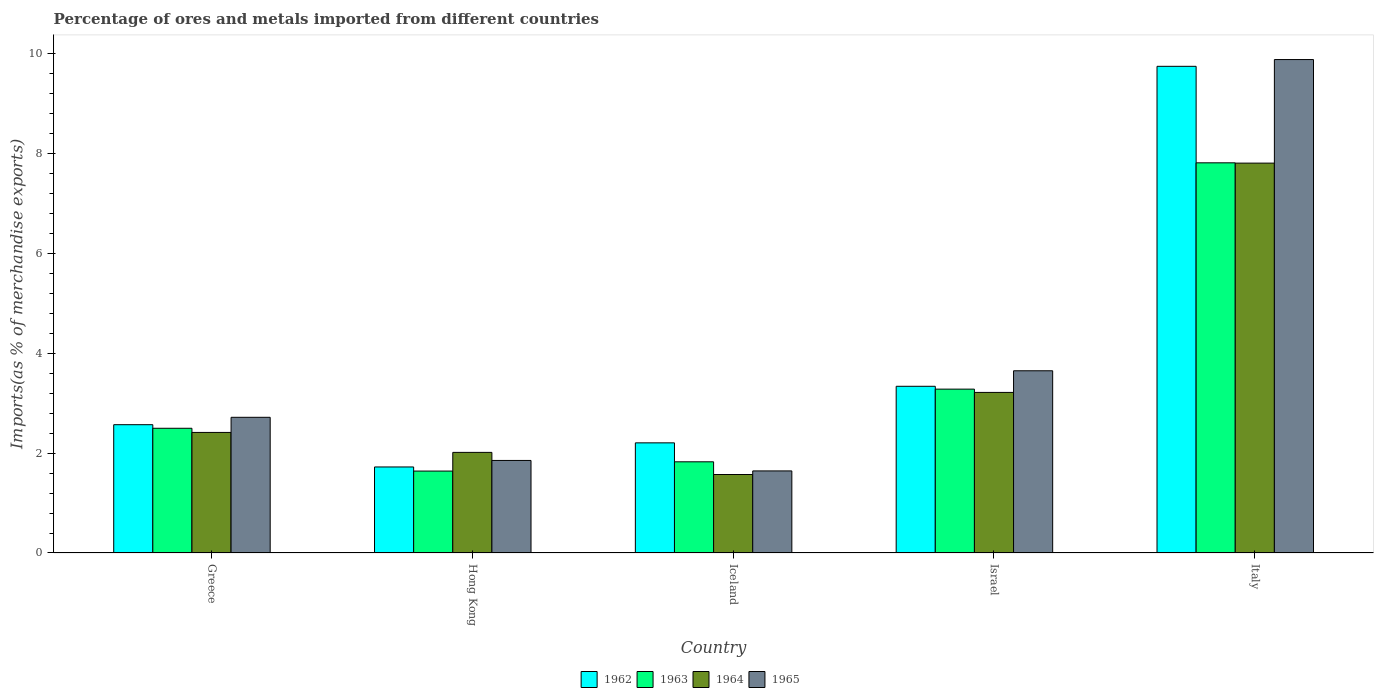How many different coloured bars are there?
Your answer should be compact. 4. Are the number of bars on each tick of the X-axis equal?
Your response must be concise. Yes. How many bars are there on the 1st tick from the left?
Your response must be concise. 4. What is the percentage of imports to different countries in 1964 in Greece?
Offer a terse response. 2.42. Across all countries, what is the maximum percentage of imports to different countries in 1965?
Give a very brief answer. 9.89. Across all countries, what is the minimum percentage of imports to different countries in 1963?
Keep it short and to the point. 1.64. What is the total percentage of imports to different countries in 1965 in the graph?
Make the answer very short. 19.76. What is the difference between the percentage of imports to different countries in 1962 in Iceland and that in Israel?
Provide a short and direct response. -1.13. What is the difference between the percentage of imports to different countries in 1962 in Iceland and the percentage of imports to different countries in 1963 in Italy?
Provide a succinct answer. -5.61. What is the average percentage of imports to different countries in 1964 per country?
Provide a succinct answer. 3.41. What is the difference between the percentage of imports to different countries of/in 1964 and percentage of imports to different countries of/in 1962 in Iceland?
Make the answer very short. -0.63. What is the ratio of the percentage of imports to different countries in 1963 in Hong Kong to that in Iceland?
Your response must be concise. 0.9. Is the percentage of imports to different countries in 1964 in Greece less than that in Italy?
Provide a short and direct response. Yes. What is the difference between the highest and the second highest percentage of imports to different countries in 1962?
Your response must be concise. 7.18. What is the difference between the highest and the lowest percentage of imports to different countries in 1962?
Offer a very short reply. 8.03. What does the 2nd bar from the right in Italy represents?
Give a very brief answer. 1964. Is it the case that in every country, the sum of the percentage of imports to different countries in 1963 and percentage of imports to different countries in 1965 is greater than the percentage of imports to different countries in 1964?
Make the answer very short. Yes. Are the values on the major ticks of Y-axis written in scientific E-notation?
Provide a short and direct response. No. Does the graph contain any zero values?
Keep it short and to the point. No. Where does the legend appear in the graph?
Keep it short and to the point. Bottom center. How many legend labels are there?
Offer a terse response. 4. What is the title of the graph?
Ensure brevity in your answer.  Percentage of ores and metals imported from different countries. Does "1999" appear as one of the legend labels in the graph?
Offer a terse response. No. What is the label or title of the X-axis?
Your response must be concise. Country. What is the label or title of the Y-axis?
Ensure brevity in your answer.  Imports(as % of merchandise exports). What is the Imports(as % of merchandise exports) of 1962 in Greece?
Your answer should be very brief. 2.57. What is the Imports(as % of merchandise exports) of 1963 in Greece?
Your response must be concise. 2.5. What is the Imports(as % of merchandise exports) of 1964 in Greece?
Your answer should be compact. 2.42. What is the Imports(as % of merchandise exports) of 1965 in Greece?
Ensure brevity in your answer.  2.72. What is the Imports(as % of merchandise exports) of 1962 in Hong Kong?
Keep it short and to the point. 1.72. What is the Imports(as % of merchandise exports) of 1963 in Hong Kong?
Your answer should be compact. 1.64. What is the Imports(as % of merchandise exports) in 1964 in Hong Kong?
Offer a terse response. 2.02. What is the Imports(as % of merchandise exports) of 1965 in Hong Kong?
Provide a short and direct response. 1.85. What is the Imports(as % of merchandise exports) of 1962 in Iceland?
Offer a very short reply. 2.21. What is the Imports(as % of merchandise exports) in 1963 in Iceland?
Your answer should be compact. 1.83. What is the Imports(as % of merchandise exports) of 1964 in Iceland?
Ensure brevity in your answer.  1.57. What is the Imports(as % of merchandise exports) of 1965 in Iceland?
Your answer should be compact. 1.64. What is the Imports(as % of merchandise exports) in 1962 in Israel?
Give a very brief answer. 3.34. What is the Imports(as % of merchandise exports) in 1963 in Israel?
Make the answer very short. 3.28. What is the Imports(as % of merchandise exports) in 1964 in Israel?
Make the answer very short. 3.22. What is the Imports(as % of merchandise exports) of 1965 in Israel?
Your answer should be very brief. 3.65. What is the Imports(as % of merchandise exports) of 1962 in Italy?
Offer a very short reply. 9.75. What is the Imports(as % of merchandise exports) of 1963 in Italy?
Provide a succinct answer. 7.82. What is the Imports(as % of merchandise exports) in 1964 in Italy?
Provide a short and direct response. 7.81. What is the Imports(as % of merchandise exports) in 1965 in Italy?
Provide a short and direct response. 9.89. Across all countries, what is the maximum Imports(as % of merchandise exports) in 1962?
Offer a terse response. 9.75. Across all countries, what is the maximum Imports(as % of merchandise exports) of 1963?
Ensure brevity in your answer.  7.82. Across all countries, what is the maximum Imports(as % of merchandise exports) of 1964?
Your response must be concise. 7.81. Across all countries, what is the maximum Imports(as % of merchandise exports) in 1965?
Ensure brevity in your answer.  9.89. Across all countries, what is the minimum Imports(as % of merchandise exports) of 1962?
Provide a short and direct response. 1.72. Across all countries, what is the minimum Imports(as % of merchandise exports) in 1963?
Your answer should be compact. 1.64. Across all countries, what is the minimum Imports(as % of merchandise exports) of 1964?
Your response must be concise. 1.57. Across all countries, what is the minimum Imports(as % of merchandise exports) in 1965?
Your response must be concise. 1.64. What is the total Imports(as % of merchandise exports) of 1962 in the graph?
Your answer should be compact. 19.59. What is the total Imports(as % of merchandise exports) of 1963 in the graph?
Your answer should be compact. 17.07. What is the total Imports(as % of merchandise exports) in 1964 in the graph?
Your response must be concise. 17.03. What is the total Imports(as % of merchandise exports) in 1965 in the graph?
Keep it short and to the point. 19.76. What is the difference between the Imports(as % of merchandise exports) in 1962 in Greece and that in Hong Kong?
Make the answer very short. 0.85. What is the difference between the Imports(as % of merchandise exports) of 1963 in Greece and that in Hong Kong?
Give a very brief answer. 0.86. What is the difference between the Imports(as % of merchandise exports) of 1964 in Greece and that in Hong Kong?
Your response must be concise. 0.4. What is the difference between the Imports(as % of merchandise exports) in 1965 in Greece and that in Hong Kong?
Keep it short and to the point. 0.86. What is the difference between the Imports(as % of merchandise exports) in 1962 in Greece and that in Iceland?
Make the answer very short. 0.36. What is the difference between the Imports(as % of merchandise exports) of 1963 in Greece and that in Iceland?
Offer a terse response. 0.67. What is the difference between the Imports(as % of merchandise exports) of 1964 in Greece and that in Iceland?
Your answer should be very brief. 0.84. What is the difference between the Imports(as % of merchandise exports) of 1965 in Greece and that in Iceland?
Provide a succinct answer. 1.07. What is the difference between the Imports(as % of merchandise exports) in 1962 in Greece and that in Israel?
Make the answer very short. -0.77. What is the difference between the Imports(as % of merchandise exports) of 1963 in Greece and that in Israel?
Offer a very short reply. -0.78. What is the difference between the Imports(as % of merchandise exports) of 1964 in Greece and that in Israel?
Offer a terse response. -0.8. What is the difference between the Imports(as % of merchandise exports) of 1965 in Greece and that in Israel?
Your response must be concise. -0.93. What is the difference between the Imports(as % of merchandise exports) of 1962 in Greece and that in Italy?
Provide a short and direct response. -7.18. What is the difference between the Imports(as % of merchandise exports) in 1963 in Greece and that in Italy?
Your answer should be compact. -5.32. What is the difference between the Imports(as % of merchandise exports) in 1964 in Greece and that in Italy?
Provide a short and direct response. -5.4. What is the difference between the Imports(as % of merchandise exports) of 1965 in Greece and that in Italy?
Your answer should be compact. -7.17. What is the difference between the Imports(as % of merchandise exports) of 1962 in Hong Kong and that in Iceland?
Ensure brevity in your answer.  -0.48. What is the difference between the Imports(as % of merchandise exports) in 1963 in Hong Kong and that in Iceland?
Provide a succinct answer. -0.19. What is the difference between the Imports(as % of merchandise exports) in 1964 in Hong Kong and that in Iceland?
Keep it short and to the point. 0.44. What is the difference between the Imports(as % of merchandise exports) in 1965 in Hong Kong and that in Iceland?
Provide a short and direct response. 0.21. What is the difference between the Imports(as % of merchandise exports) of 1962 in Hong Kong and that in Israel?
Provide a succinct answer. -1.62. What is the difference between the Imports(as % of merchandise exports) of 1963 in Hong Kong and that in Israel?
Give a very brief answer. -1.64. What is the difference between the Imports(as % of merchandise exports) in 1964 in Hong Kong and that in Israel?
Give a very brief answer. -1.2. What is the difference between the Imports(as % of merchandise exports) in 1965 in Hong Kong and that in Israel?
Provide a short and direct response. -1.8. What is the difference between the Imports(as % of merchandise exports) in 1962 in Hong Kong and that in Italy?
Make the answer very short. -8.03. What is the difference between the Imports(as % of merchandise exports) of 1963 in Hong Kong and that in Italy?
Offer a terse response. -6.18. What is the difference between the Imports(as % of merchandise exports) of 1964 in Hong Kong and that in Italy?
Provide a short and direct response. -5.8. What is the difference between the Imports(as % of merchandise exports) in 1965 in Hong Kong and that in Italy?
Provide a succinct answer. -8.03. What is the difference between the Imports(as % of merchandise exports) in 1962 in Iceland and that in Israel?
Offer a very short reply. -1.13. What is the difference between the Imports(as % of merchandise exports) of 1963 in Iceland and that in Israel?
Ensure brevity in your answer.  -1.46. What is the difference between the Imports(as % of merchandise exports) of 1964 in Iceland and that in Israel?
Your response must be concise. -1.65. What is the difference between the Imports(as % of merchandise exports) of 1965 in Iceland and that in Israel?
Your answer should be compact. -2.01. What is the difference between the Imports(as % of merchandise exports) of 1962 in Iceland and that in Italy?
Offer a very short reply. -7.54. What is the difference between the Imports(as % of merchandise exports) in 1963 in Iceland and that in Italy?
Give a very brief answer. -5.99. What is the difference between the Imports(as % of merchandise exports) of 1964 in Iceland and that in Italy?
Your answer should be very brief. -6.24. What is the difference between the Imports(as % of merchandise exports) in 1965 in Iceland and that in Italy?
Ensure brevity in your answer.  -8.24. What is the difference between the Imports(as % of merchandise exports) of 1962 in Israel and that in Italy?
Provide a short and direct response. -6.41. What is the difference between the Imports(as % of merchandise exports) of 1963 in Israel and that in Italy?
Keep it short and to the point. -4.53. What is the difference between the Imports(as % of merchandise exports) in 1964 in Israel and that in Italy?
Make the answer very short. -4.59. What is the difference between the Imports(as % of merchandise exports) in 1965 in Israel and that in Italy?
Give a very brief answer. -6.24. What is the difference between the Imports(as % of merchandise exports) in 1962 in Greece and the Imports(as % of merchandise exports) in 1963 in Hong Kong?
Keep it short and to the point. 0.93. What is the difference between the Imports(as % of merchandise exports) in 1962 in Greece and the Imports(as % of merchandise exports) in 1964 in Hong Kong?
Offer a very short reply. 0.55. What is the difference between the Imports(as % of merchandise exports) of 1962 in Greece and the Imports(as % of merchandise exports) of 1965 in Hong Kong?
Your response must be concise. 0.72. What is the difference between the Imports(as % of merchandise exports) of 1963 in Greece and the Imports(as % of merchandise exports) of 1964 in Hong Kong?
Your answer should be very brief. 0.48. What is the difference between the Imports(as % of merchandise exports) in 1963 in Greece and the Imports(as % of merchandise exports) in 1965 in Hong Kong?
Give a very brief answer. 0.64. What is the difference between the Imports(as % of merchandise exports) of 1964 in Greece and the Imports(as % of merchandise exports) of 1965 in Hong Kong?
Your answer should be compact. 0.56. What is the difference between the Imports(as % of merchandise exports) of 1962 in Greece and the Imports(as % of merchandise exports) of 1963 in Iceland?
Offer a terse response. 0.74. What is the difference between the Imports(as % of merchandise exports) of 1962 in Greece and the Imports(as % of merchandise exports) of 1964 in Iceland?
Provide a succinct answer. 1. What is the difference between the Imports(as % of merchandise exports) in 1962 in Greece and the Imports(as % of merchandise exports) in 1965 in Iceland?
Give a very brief answer. 0.93. What is the difference between the Imports(as % of merchandise exports) in 1963 in Greece and the Imports(as % of merchandise exports) in 1964 in Iceland?
Offer a very short reply. 0.93. What is the difference between the Imports(as % of merchandise exports) in 1963 in Greece and the Imports(as % of merchandise exports) in 1965 in Iceland?
Give a very brief answer. 0.85. What is the difference between the Imports(as % of merchandise exports) in 1964 in Greece and the Imports(as % of merchandise exports) in 1965 in Iceland?
Make the answer very short. 0.77. What is the difference between the Imports(as % of merchandise exports) in 1962 in Greece and the Imports(as % of merchandise exports) in 1963 in Israel?
Provide a succinct answer. -0.71. What is the difference between the Imports(as % of merchandise exports) of 1962 in Greece and the Imports(as % of merchandise exports) of 1964 in Israel?
Your answer should be very brief. -0.65. What is the difference between the Imports(as % of merchandise exports) in 1962 in Greece and the Imports(as % of merchandise exports) in 1965 in Israel?
Provide a short and direct response. -1.08. What is the difference between the Imports(as % of merchandise exports) in 1963 in Greece and the Imports(as % of merchandise exports) in 1964 in Israel?
Give a very brief answer. -0.72. What is the difference between the Imports(as % of merchandise exports) in 1963 in Greece and the Imports(as % of merchandise exports) in 1965 in Israel?
Give a very brief answer. -1.15. What is the difference between the Imports(as % of merchandise exports) of 1964 in Greece and the Imports(as % of merchandise exports) of 1965 in Israel?
Provide a succinct answer. -1.24. What is the difference between the Imports(as % of merchandise exports) of 1962 in Greece and the Imports(as % of merchandise exports) of 1963 in Italy?
Offer a very short reply. -5.25. What is the difference between the Imports(as % of merchandise exports) in 1962 in Greece and the Imports(as % of merchandise exports) in 1964 in Italy?
Keep it short and to the point. -5.24. What is the difference between the Imports(as % of merchandise exports) of 1962 in Greece and the Imports(as % of merchandise exports) of 1965 in Italy?
Ensure brevity in your answer.  -7.32. What is the difference between the Imports(as % of merchandise exports) of 1963 in Greece and the Imports(as % of merchandise exports) of 1964 in Italy?
Offer a terse response. -5.31. What is the difference between the Imports(as % of merchandise exports) in 1963 in Greece and the Imports(as % of merchandise exports) in 1965 in Italy?
Offer a terse response. -7.39. What is the difference between the Imports(as % of merchandise exports) in 1964 in Greece and the Imports(as % of merchandise exports) in 1965 in Italy?
Keep it short and to the point. -7.47. What is the difference between the Imports(as % of merchandise exports) of 1962 in Hong Kong and the Imports(as % of merchandise exports) of 1963 in Iceland?
Your answer should be compact. -0.1. What is the difference between the Imports(as % of merchandise exports) of 1962 in Hong Kong and the Imports(as % of merchandise exports) of 1964 in Iceland?
Give a very brief answer. 0.15. What is the difference between the Imports(as % of merchandise exports) in 1962 in Hong Kong and the Imports(as % of merchandise exports) in 1965 in Iceland?
Ensure brevity in your answer.  0.08. What is the difference between the Imports(as % of merchandise exports) in 1963 in Hong Kong and the Imports(as % of merchandise exports) in 1964 in Iceland?
Your answer should be compact. 0.07. What is the difference between the Imports(as % of merchandise exports) of 1963 in Hong Kong and the Imports(as % of merchandise exports) of 1965 in Iceland?
Your response must be concise. -0. What is the difference between the Imports(as % of merchandise exports) of 1964 in Hong Kong and the Imports(as % of merchandise exports) of 1965 in Iceland?
Keep it short and to the point. 0.37. What is the difference between the Imports(as % of merchandise exports) of 1962 in Hong Kong and the Imports(as % of merchandise exports) of 1963 in Israel?
Make the answer very short. -1.56. What is the difference between the Imports(as % of merchandise exports) in 1962 in Hong Kong and the Imports(as % of merchandise exports) in 1964 in Israel?
Your answer should be compact. -1.49. What is the difference between the Imports(as % of merchandise exports) of 1962 in Hong Kong and the Imports(as % of merchandise exports) of 1965 in Israel?
Offer a very short reply. -1.93. What is the difference between the Imports(as % of merchandise exports) in 1963 in Hong Kong and the Imports(as % of merchandise exports) in 1964 in Israel?
Offer a terse response. -1.58. What is the difference between the Imports(as % of merchandise exports) in 1963 in Hong Kong and the Imports(as % of merchandise exports) in 1965 in Israel?
Your answer should be compact. -2.01. What is the difference between the Imports(as % of merchandise exports) in 1964 in Hong Kong and the Imports(as % of merchandise exports) in 1965 in Israel?
Give a very brief answer. -1.64. What is the difference between the Imports(as % of merchandise exports) in 1962 in Hong Kong and the Imports(as % of merchandise exports) in 1963 in Italy?
Provide a short and direct response. -6.09. What is the difference between the Imports(as % of merchandise exports) of 1962 in Hong Kong and the Imports(as % of merchandise exports) of 1964 in Italy?
Ensure brevity in your answer.  -6.09. What is the difference between the Imports(as % of merchandise exports) in 1962 in Hong Kong and the Imports(as % of merchandise exports) in 1965 in Italy?
Keep it short and to the point. -8.16. What is the difference between the Imports(as % of merchandise exports) of 1963 in Hong Kong and the Imports(as % of merchandise exports) of 1964 in Italy?
Your answer should be compact. -6.17. What is the difference between the Imports(as % of merchandise exports) in 1963 in Hong Kong and the Imports(as % of merchandise exports) in 1965 in Italy?
Ensure brevity in your answer.  -8.25. What is the difference between the Imports(as % of merchandise exports) of 1964 in Hong Kong and the Imports(as % of merchandise exports) of 1965 in Italy?
Provide a succinct answer. -7.87. What is the difference between the Imports(as % of merchandise exports) of 1962 in Iceland and the Imports(as % of merchandise exports) of 1963 in Israel?
Provide a succinct answer. -1.08. What is the difference between the Imports(as % of merchandise exports) of 1962 in Iceland and the Imports(as % of merchandise exports) of 1964 in Israel?
Your answer should be very brief. -1.01. What is the difference between the Imports(as % of merchandise exports) in 1962 in Iceland and the Imports(as % of merchandise exports) in 1965 in Israel?
Ensure brevity in your answer.  -1.44. What is the difference between the Imports(as % of merchandise exports) in 1963 in Iceland and the Imports(as % of merchandise exports) in 1964 in Israel?
Your response must be concise. -1.39. What is the difference between the Imports(as % of merchandise exports) of 1963 in Iceland and the Imports(as % of merchandise exports) of 1965 in Israel?
Provide a short and direct response. -1.82. What is the difference between the Imports(as % of merchandise exports) in 1964 in Iceland and the Imports(as % of merchandise exports) in 1965 in Israel?
Offer a terse response. -2.08. What is the difference between the Imports(as % of merchandise exports) of 1962 in Iceland and the Imports(as % of merchandise exports) of 1963 in Italy?
Your answer should be very brief. -5.61. What is the difference between the Imports(as % of merchandise exports) of 1962 in Iceland and the Imports(as % of merchandise exports) of 1964 in Italy?
Ensure brevity in your answer.  -5.61. What is the difference between the Imports(as % of merchandise exports) in 1962 in Iceland and the Imports(as % of merchandise exports) in 1965 in Italy?
Provide a short and direct response. -7.68. What is the difference between the Imports(as % of merchandise exports) of 1963 in Iceland and the Imports(as % of merchandise exports) of 1964 in Italy?
Offer a terse response. -5.98. What is the difference between the Imports(as % of merchandise exports) of 1963 in Iceland and the Imports(as % of merchandise exports) of 1965 in Italy?
Provide a succinct answer. -8.06. What is the difference between the Imports(as % of merchandise exports) in 1964 in Iceland and the Imports(as % of merchandise exports) in 1965 in Italy?
Offer a very short reply. -8.31. What is the difference between the Imports(as % of merchandise exports) of 1962 in Israel and the Imports(as % of merchandise exports) of 1963 in Italy?
Your response must be concise. -4.48. What is the difference between the Imports(as % of merchandise exports) in 1962 in Israel and the Imports(as % of merchandise exports) in 1964 in Italy?
Your answer should be very brief. -4.47. What is the difference between the Imports(as % of merchandise exports) in 1962 in Israel and the Imports(as % of merchandise exports) in 1965 in Italy?
Offer a terse response. -6.55. What is the difference between the Imports(as % of merchandise exports) in 1963 in Israel and the Imports(as % of merchandise exports) in 1964 in Italy?
Offer a terse response. -4.53. What is the difference between the Imports(as % of merchandise exports) in 1963 in Israel and the Imports(as % of merchandise exports) in 1965 in Italy?
Provide a short and direct response. -6.6. What is the difference between the Imports(as % of merchandise exports) in 1964 in Israel and the Imports(as % of merchandise exports) in 1965 in Italy?
Provide a succinct answer. -6.67. What is the average Imports(as % of merchandise exports) in 1962 per country?
Provide a short and direct response. 3.92. What is the average Imports(as % of merchandise exports) in 1963 per country?
Provide a short and direct response. 3.41. What is the average Imports(as % of merchandise exports) in 1964 per country?
Provide a succinct answer. 3.41. What is the average Imports(as % of merchandise exports) of 1965 per country?
Give a very brief answer. 3.95. What is the difference between the Imports(as % of merchandise exports) in 1962 and Imports(as % of merchandise exports) in 1963 in Greece?
Offer a terse response. 0.07. What is the difference between the Imports(as % of merchandise exports) of 1962 and Imports(as % of merchandise exports) of 1964 in Greece?
Offer a terse response. 0.16. What is the difference between the Imports(as % of merchandise exports) in 1962 and Imports(as % of merchandise exports) in 1965 in Greece?
Keep it short and to the point. -0.15. What is the difference between the Imports(as % of merchandise exports) in 1963 and Imports(as % of merchandise exports) in 1964 in Greece?
Offer a terse response. 0.08. What is the difference between the Imports(as % of merchandise exports) in 1963 and Imports(as % of merchandise exports) in 1965 in Greece?
Offer a terse response. -0.22. What is the difference between the Imports(as % of merchandise exports) of 1964 and Imports(as % of merchandise exports) of 1965 in Greece?
Offer a very short reply. -0.3. What is the difference between the Imports(as % of merchandise exports) of 1962 and Imports(as % of merchandise exports) of 1963 in Hong Kong?
Provide a succinct answer. 0.08. What is the difference between the Imports(as % of merchandise exports) in 1962 and Imports(as % of merchandise exports) in 1964 in Hong Kong?
Offer a terse response. -0.29. What is the difference between the Imports(as % of merchandise exports) of 1962 and Imports(as % of merchandise exports) of 1965 in Hong Kong?
Make the answer very short. -0.13. What is the difference between the Imports(as % of merchandise exports) in 1963 and Imports(as % of merchandise exports) in 1964 in Hong Kong?
Offer a very short reply. -0.37. What is the difference between the Imports(as % of merchandise exports) of 1963 and Imports(as % of merchandise exports) of 1965 in Hong Kong?
Provide a short and direct response. -0.21. What is the difference between the Imports(as % of merchandise exports) of 1964 and Imports(as % of merchandise exports) of 1965 in Hong Kong?
Make the answer very short. 0.16. What is the difference between the Imports(as % of merchandise exports) of 1962 and Imports(as % of merchandise exports) of 1963 in Iceland?
Provide a short and direct response. 0.38. What is the difference between the Imports(as % of merchandise exports) of 1962 and Imports(as % of merchandise exports) of 1964 in Iceland?
Provide a short and direct response. 0.63. What is the difference between the Imports(as % of merchandise exports) of 1962 and Imports(as % of merchandise exports) of 1965 in Iceland?
Keep it short and to the point. 0.56. What is the difference between the Imports(as % of merchandise exports) of 1963 and Imports(as % of merchandise exports) of 1964 in Iceland?
Your answer should be very brief. 0.25. What is the difference between the Imports(as % of merchandise exports) of 1963 and Imports(as % of merchandise exports) of 1965 in Iceland?
Ensure brevity in your answer.  0.18. What is the difference between the Imports(as % of merchandise exports) of 1964 and Imports(as % of merchandise exports) of 1965 in Iceland?
Give a very brief answer. -0.07. What is the difference between the Imports(as % of merchandise exports) in 1962 and Imports(as % of merchandise exports) in 1963 in Israel?
Give a very brief answer. 0.06. What is the difference between the Imports(as % of merchandise exports) of 1962 and Imports(as % of merchandise exports) of 1964 in Israel?
Keep it short and to the point. 0.12. What is the difference between the Imports(as % of merchandise exports) of 1962 and Imports(as % of merchandise exports) of 1965 in Israel?
Give a very brief answer. -0.31. What is the difference between the Imports(as % of merchandise exports) of 1963 and Imports(as % of merchandise exports) of 1964 in Israel?
Your answer should be compact. 0.07. What is the difference between the Imports(as % of merchandise exports) of 1963 and Imports(as % of merchandise exports) of 1965 in Israel?
Keep it short and to the point. -0.37. What is the difference between the Imports(as % of merchandise exports) in 1964 and Imports(as % of merchandise exports) in 1965 in Israel?
Offer a very short reply. -0.43. What is the difference between the Imports(as % of merchandise exports) in 1962 and Imports(as % of merchandise exports) in 1963 in Italy?
Your answer should be compact. 1.93. What is the difference between the Imports(as % of merchandise exports) of 1962 and Imports(as % of merchandise exports) of 1964 in Italy?
Keep it short and to the point. 1.94. What is the difference between the Imports(as % of merchandise exports) of 1962 and Imports(as % of merchandise exports) of 1965 in Italy?
Your answer should be very brief. -0.14. What is the difference between the Imports(as % of merchandise exports) in 1963 and Imports(as % of merchandise exports) in 1964 in Italy?
Ensure brevity in your answer.  0.01. What is the difference between the Imports(as % of merchandise exports) in 1963 and Imports(as % of merchandise exports) in 1965 in Italy?
Provide a succinct answer. -2.07. What is the difference between the Imports(as % of merchandise exports) in 1964 and Imports(as % of merchandise exports) in 1965 in Italy?
Make the answer very short. -2.08. What is the ratio of the Imports(as % of merchandise exports) of 1962 in Greece to that in Hong Kong?
Your answer should be very brief. 1.49. What is the ratio of the Imports(as % of merchandise exports) of 1963 in Greece to that in Hong Kong?
Offer a very short reply. 1.52. What is the ratio of the Imports(as % of merchandise exports) in 1964 in Greece to that in Hong Kong?
Provide a succinct answer. 1.2. What is the ratio of the Imports(as % of merchandise exports) of 1965 in Greece to that in Hong Kong?
Offer a terse response. 1.47. What is the ratio of the Imports(as % of merchandise exports) in 1962 in Greece to that in Iceland?
Provide a succinct answer. 1.16. What is the ratio of the Imports(as % of merchandise exports) of 1963 in Greece to that in Iceland?
Your response must be concise. 1.37. What is the ratio of the Imports(as % of merchandise exports) in 1964 in Greece to that in Iceland?
Ensure brevity in your answer.  1.54. What is the ratio of the Imports(as % of merchandise exports) in 1965 in Greece to that in Iceland?
Offer a terse response. 1.65. What is the ratio of the Imports(as % of merchandise exports) of 1962 in Greece to that in Israel?
Ensure brevity in your answer.  0.77. What is the ratio of the Imports(as % of merchandise exports) in 1963 in Greece to that in Israel?
Keep it short and to the point. 0.76. What is the ratio of the Imports(as % of merchandise exports) in 1964 in Greece to that in Israel?
Provide a succinct answer. 0.75. What is the ratio of the Imports(as % of merchandise exports) in 1965 in Greece to that in Israel?
Your response must be concise. 0.74. What is the ratio of the Imports(as % of merchandise exports) of 1962 in Greece to that in Italy?
Offer a terse response. 0.26. What is the ratio of the Imports(as % of merchandise exports) in 1963 in Greece to that in Italy?
Offer a very short reply. 0.32. What is the ratio of the Imports(as % of merchandise exports) of 1964 in Greece to that in Italy?
Provide a succinct answer. 0.31. What is the ratio of the Imports(as % of merchandise exports) of 1965 in Greece to that in Italy?
Provide a succinct answer. 0.28. What is the ratio of the Imports(as % of merchandise exports) of 1962 in Hong Kong to that in Iceland?
Give a very brief answer. 0.78. What is the ratio of the Imports(as % of merchandise exports) of 1963 in Hong Kong to that in Iceland?
Offer a terse response. 0.9. What is the ratio of the Imports(as % of merchandise exports) of 1964 in Hong Kong to that in Iceland?
Provide a succinct answer. 1.28. What is the ratio of the Imports(as % of merchandise exports) of 1965 in Hong Kong to that in Iceland?
Offer a very short reply. 1.13. What is the ratio of the Imports(as % of merchandise exports) in 1962 in Hong Kong to that in Israel?
Keep it short and to the point. 0.52. What is the ratio of the Imports(as % of merchandise exports) of 1963 in Hong Kong to that in Israel?
Your answer should be very brief. 0.5. What is the ratio of the Imports(as % of merchandise exports) of 1964 in Hong Kong to that in Israel?
Your response must be concise. 0.63. What is the ratio of the Imports(as % of merchandise exports) of 1965 in Hong Kong to that in Israel?
Give a very brief answer. 0.51. What is the ratio of the Imports(as % of merchandise exports) of 1962 in Hong Kong to that in Italy?
Ensure brevity in your answer.  0.18. What is the ratio of the Imports(as % of merchandise exports) of 1963 in Hong Kong to that in Italy?
Offer a terse response. 0.21. What is the ratio of the Imports(as % of merchandise exports) of 1964 in Hong Kong to that in Italy?
Make the answer very short. 0.26. What is the ratio of the Imports(as % of merchandise exports) in 1965 in Hong Kong to that in Italy?
Your answer should be very brief. 0.19. What is the ratio of the Imports(as % of merchandise exports) of 1962 in Iceland to that in Israel?
Keep it short and to the point. 0.66. What is the ratio of the Imports(as % of merchandise exports) of 1963 in Iceland to that in Israel?
Offer a terse response. 0.56. What is the ratio of the Imports(as % of merchandise exports) of 1964 in Iceland to that in Israel?
Keep it short and to the point. 0.49. What is the ratio of the Imports(as % of merchandise exports) in 1965 in Iceland to that in Israel?
Provide a succinct answer. 0.45. What is the ratio of the Imports(as % of merchandise exports) of 1962 in Iceland to that in Italy?
Give a very brief answer. 0.23. What is the ratio of the Imports(as % of merchandise exports) in 1963 in Iceland to that in Italy?
Ensure brevity in your answer.  0.23. What is the ratio of the Imports(as % of merchandise exports) in 1964 in Iceland to that in Italy?
Keep it short and to the point. 0.2. What is the ratio of the Imports(as % of merchandise exports) in 1965 in Iceland to that in Italy?
Keep it short and to the point. 0.17. What is the ratio of the Imports(as % of merchandise exports) of 1962 in Israel to that in Italy?
Your response must be concise. 0.34. What is the ratio of the Imports(as % of merchandise exports) in 1963 in Israel to that in Italy?
Your answer should be very brief. 0.42. What is the ratio of the Imports(as % of merchandise exports) in 1964 in Israel to that in Italy?
Ensure brevity in your answer.  0.41. What is the ratio of the Imports(as % of merchandise exports) in 1965 in Israel to that in Italy?
Offer a terse response. 0.37. What is the difference between the highest and the second highest Imports(as % of merchandise exports) of 1962?
Provide a short and direct response. 6.41. What is the difference between the highest and the second highest Imports(as % of merchandise exports) of 1963?
Provide a succinct answer. 4.53. What is the difference between the highest and the second highest Imports(as % of merchandise exports) of 1964?
Offer a terse response. 4.59. What is the difference between the highest and the second highest Imports(as % of merchandise exports) of 1965?
Ensure brevity in your answer.  6.24. What is the difference between the highest and the lowest Imports(as % of merchandise exports) in 1962?
Provide a succinct answer. 8.03. What is the difference between the highest and the lowest Imports(as % of merchandise exports) in 1963?
Ensure brevity in your answer.  6.18. What is the difference between the highest and the lowest Imports(as % of merchandise exports) of 1964?
Offer a very short reply. 6.24. What is the difference between the highest and the lowest Imports(as % of merchandise exports) in 1965?
Provide a short and direct response. 8.24. 